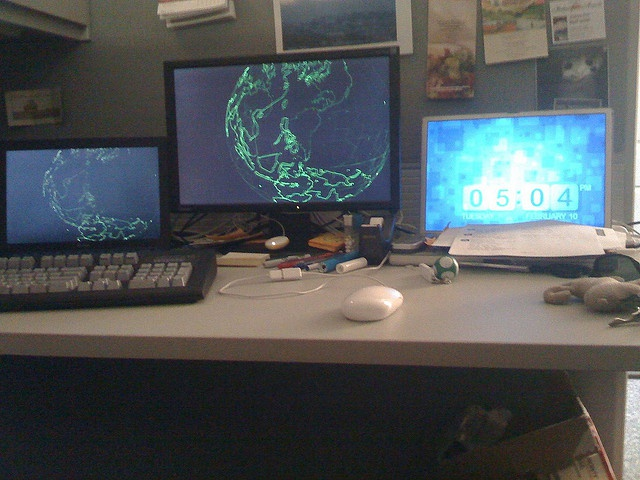Describe the objects in this image and their specific colors. I can see tv in black, gray, and blue tones, tv in black, lightblue, white, and cyan tones, tv in black, gray, and blue tones, keyboard in black and gray tones, and mouse in black, gray, tan, and white tones in this image. 